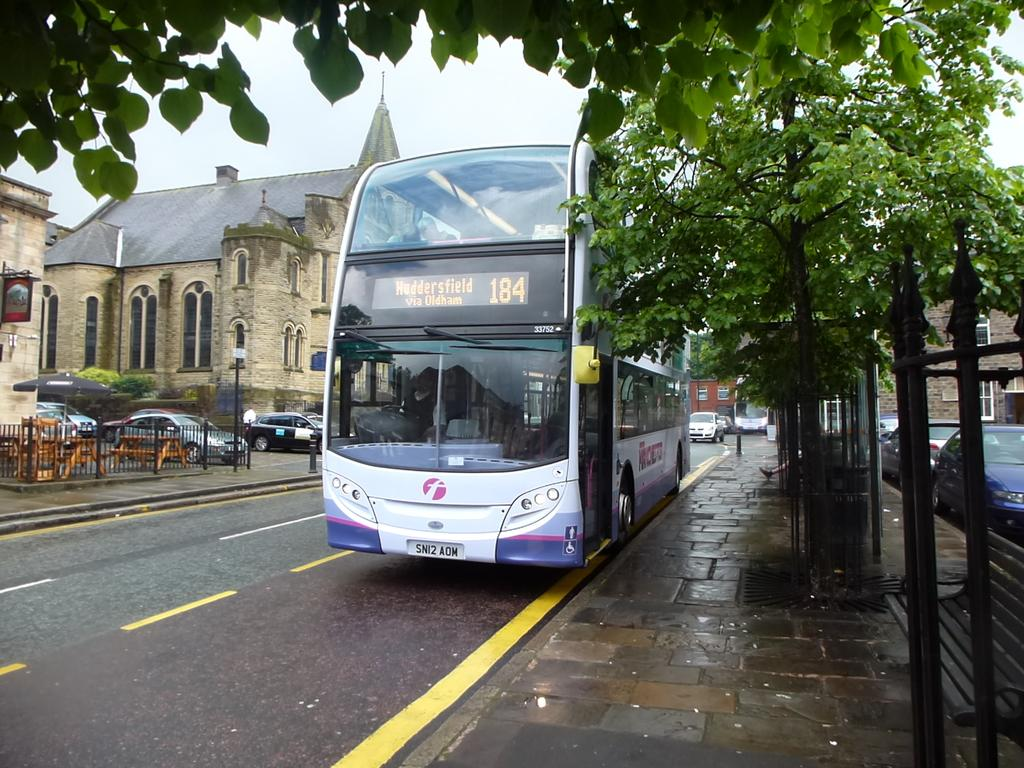What type of vehicle is in the image? There is a bus in the image. What else can be seen on the road in the image? There are cars on the road in the image. What type of natural elements are present in the image? There are trees in the image. What man-made structures can be seen in the image? There are poles and a fence in the image. What other objects are present on the ground in the image? There are other objects on the ground in the image. What can be seen in the background of the image? The sky is visible in the background of the image. What type of rhythm can be heard coming from the bus in the image? There is no indication of sound or rhythm in the image, as it is a still photograph. 